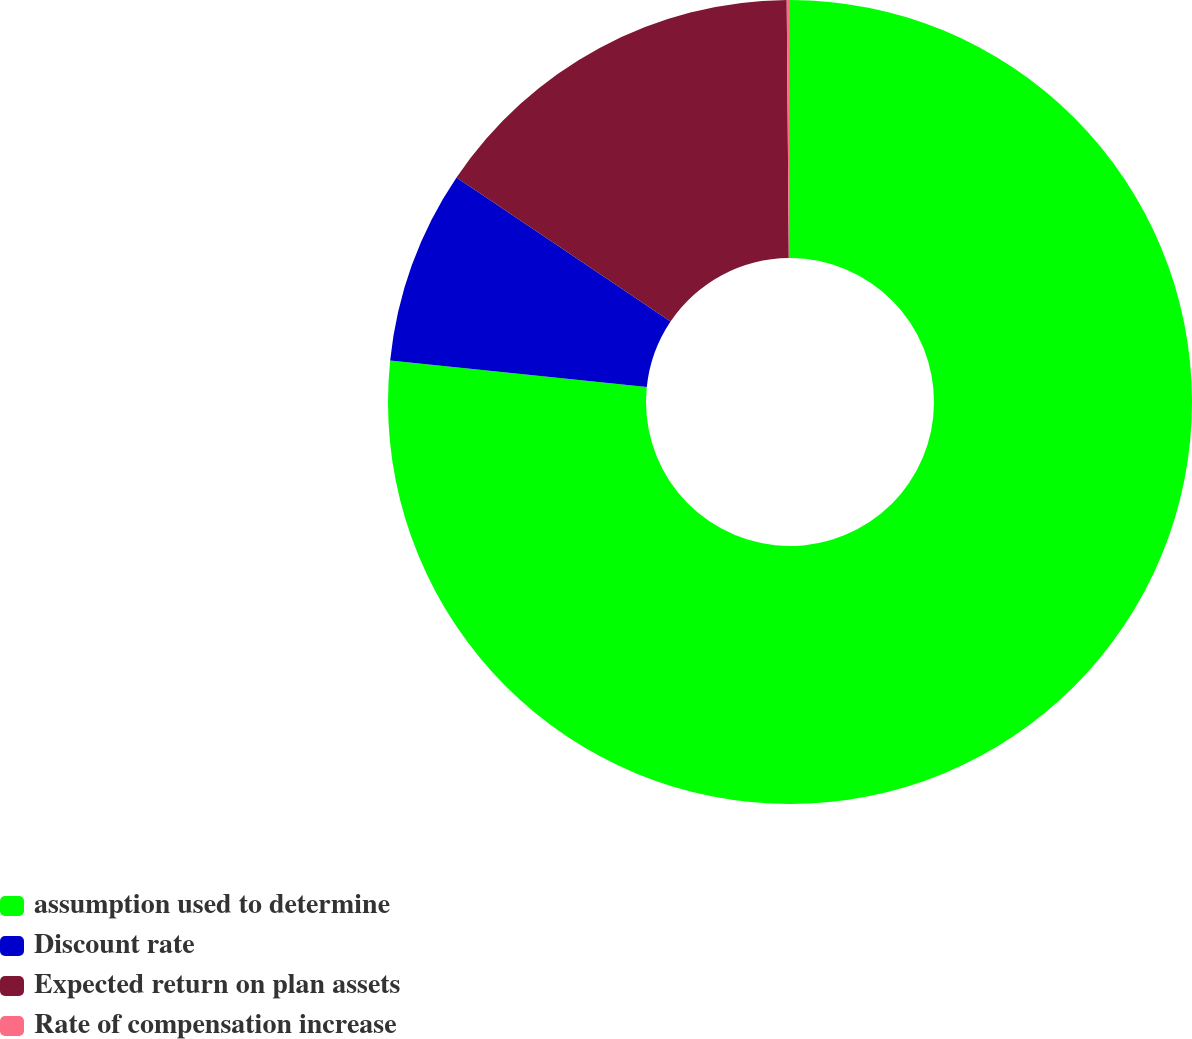Convert chart. <chart><loc_0><loc_0><loc_500><loc_500><pie_chart><fcel>assumption used to determine<fcel>Discount rate<fcel>Expected return on plan assets<fcel>Rate of compensation increase<nl><fcel>76.65%<fcel>7.78%<fcel>15.44%<fcel>0.13%<nl></chart> 